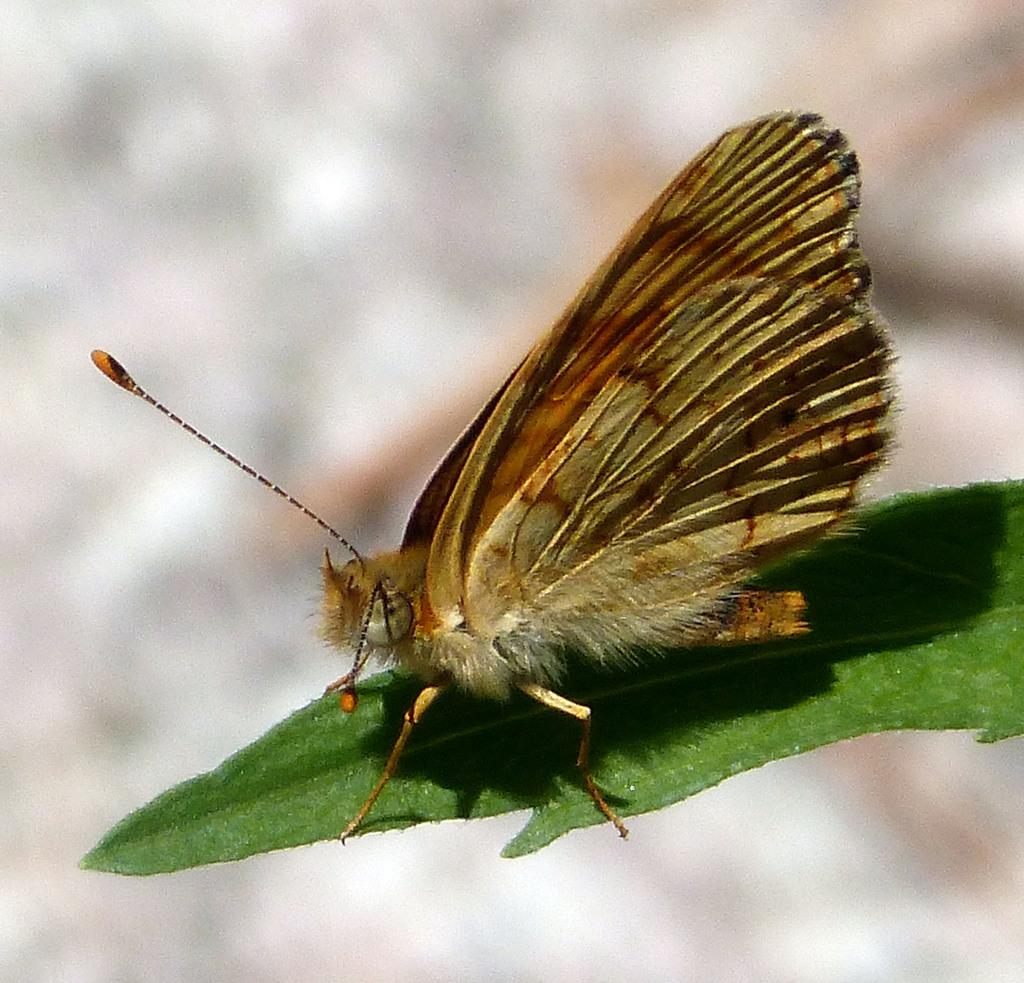What is the main subject of the image? There is a butterfly in the image. Where is the butterfly located? The butterfly is on a leaf. What color is the leaf? The leaf is green. What feature of the butterfly is mentioned in the facts? The butterfly has wings. How would you describe the background of the image? The background of the image appears blurry. What type of songs can be heard playing in the background of the image? There is no mention of songs or any audio in the image, so it cannot be determined if any songs are playing. 